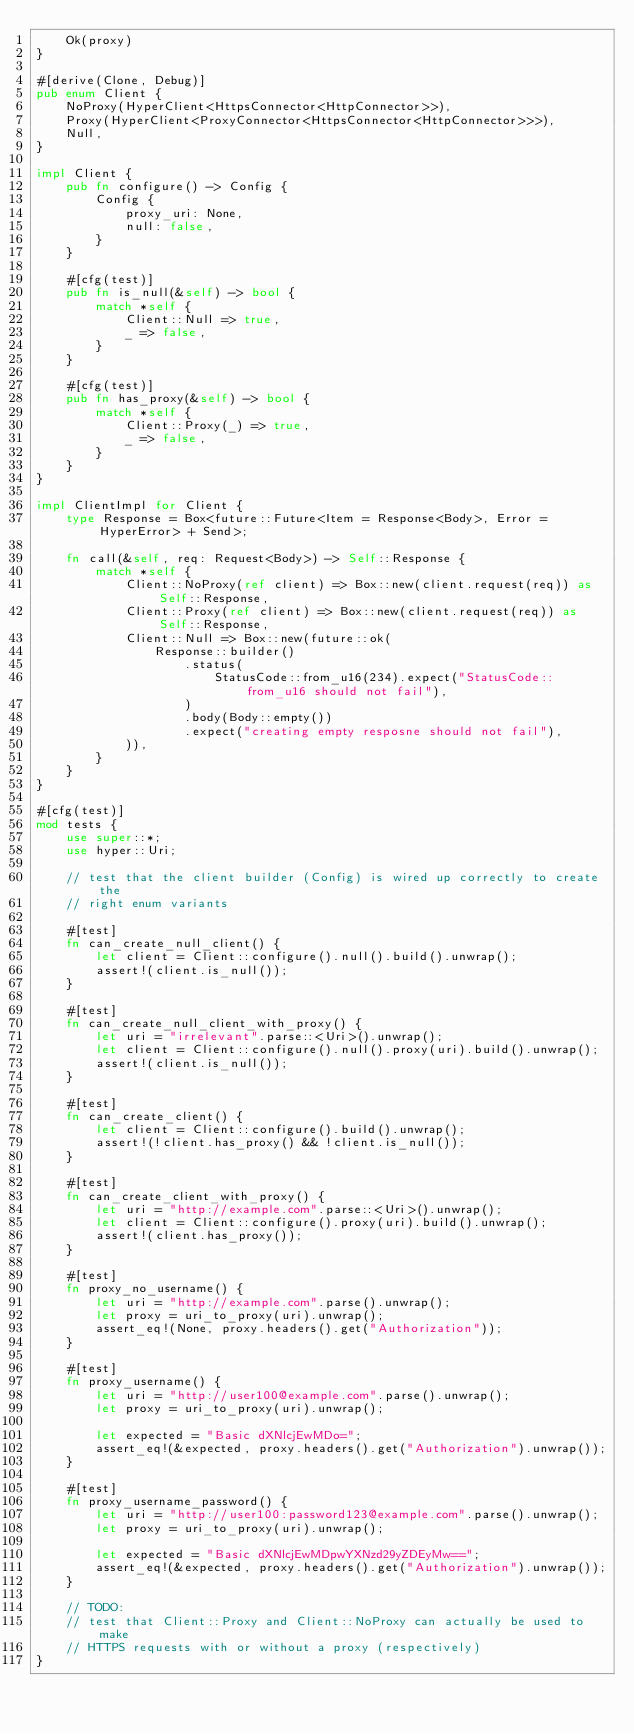Convert code to text. <code><loc_0><loc_0><loc_500><loc_500><_Rust_>    Ok(proxy)
}

#[derive(Clone, Debug)]
pub enum Client {
    NoProxy(HyperClient<HttpsConnector<HttpConnector>>),
    Proxy(HyperClient<ProxyConnector<HttpsConnector<HttpConnector>>>),
    Null,
}

impl Client {
    pub fn configure() -> Config {
        Config {
            proxy_uri: None,
            null: false,
        }
    }

    #[cfg(test)]
    pub fn is_null(&self) -> bool {
        match *self {
            Client::Null => true,
            _ => false,
        }
    }

    #[cfg(test)]
    pub fn has_proxy(&self) -> bool {
        match *self {
            Client::Proxy(_) => true,
            _ => false,
        }
    }
}

impl ClientImpl for Client {
    type Response = Box<future::Future<Item = Response<Body>, Error = HyperError> + Send>;

    fn call(&self, req: Request<Body>) -> Self::Response {
        match *self {
            Client::NoProxy(ref client) => Box::new(client.request(req)) as Self::Response,
            Client::Proxy(ref client) => Box::new(client.request(req)) as Self::Response,
            Client::Null => Box::new(future::ok(
                Response::builder()
                    .status(
                        StatusCode::from_u16(234).expect("StatusCode::from_u16 should not fail"),
                    )
                    .body(Body::empty())
                    .expect("creating empty resposne should not fail"),
            )),
        }
    }
}

#[cfg(test)]
mod tests {
    use super::*;
    use hyper::Uri;

    // test that the client builder (Config) is wired up correctly to create the
    // right enum variants

    #[test]
    fn can_create_null_client() {
        let client = Client::configure().null().build().unwrap();
        assert!(client.is_null());
    }

    #[test]
    fn can_create_null_client_with_proxy() {
        let uri = "irrelevant".parse::<Uri>().unwrap();
        let client = Client::configure().null().proxy(uri).build().unwrap();
        assert!(client.is_null());
    }

    #[test]
    fn can_create_client() {
        let client = Client::configure().build().unwrap();
        assert!(!client.has_proxy() && !client.is_null());
    }

    #[test]
    fn can_create_client_with_proxy() {
        let uri = "http://example.com".parse::<Uri>().unwrap();
        let client = Client::configure().proxy(uri).build().unwrap();
        assert!(client.has_proxy());
    }

    #[test]
    fn proxy_no_username() {
        let uri = "http://example.com".parse().unwrap();
        let proxy = uri_to_proxy(uri).unwrap();
        assert_eq!(None, proxy.headers().get("Authorization"));
    }

    #[test]
    fn proxy_username() {
        let uri = "http://user100@example.com".parse().unwrap();
        let proxy = uri_to_proxy(uri).unwrap();

        let expected = "Basic dXNlcjEwMDo=";
        assert_eq!(&expected, proxy.headers().get("Authorization").unwrap());
    }

    #[test]
    fn proxy_username_password() {
        let uri = "http://user100:password123@example.com".parse().unwrap();
        let proxy = uri_to_proxy(uri).unwrap();

        let expected = "Basic dXNlcjEwMDpwYXNzd29yZDEyMw==";
        assert_eq!(&expected, proxy.headers().get("Authorization").unwrap());
    }

    // TODO:
    // test that Client::Proxy and Client::NoProxy can actually be used to make
    // HTTPS requests with or without a proxy (respectively)
}
</code> 